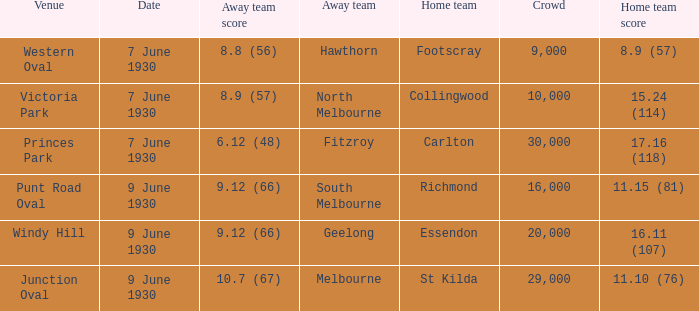What is the away team that scored 9.12 (66) at Windy Hill? Geelong. 